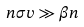<formula> <loc_0><loc_0><loc_500><loc_500>n \sigma v \gg \beta n</formula> 